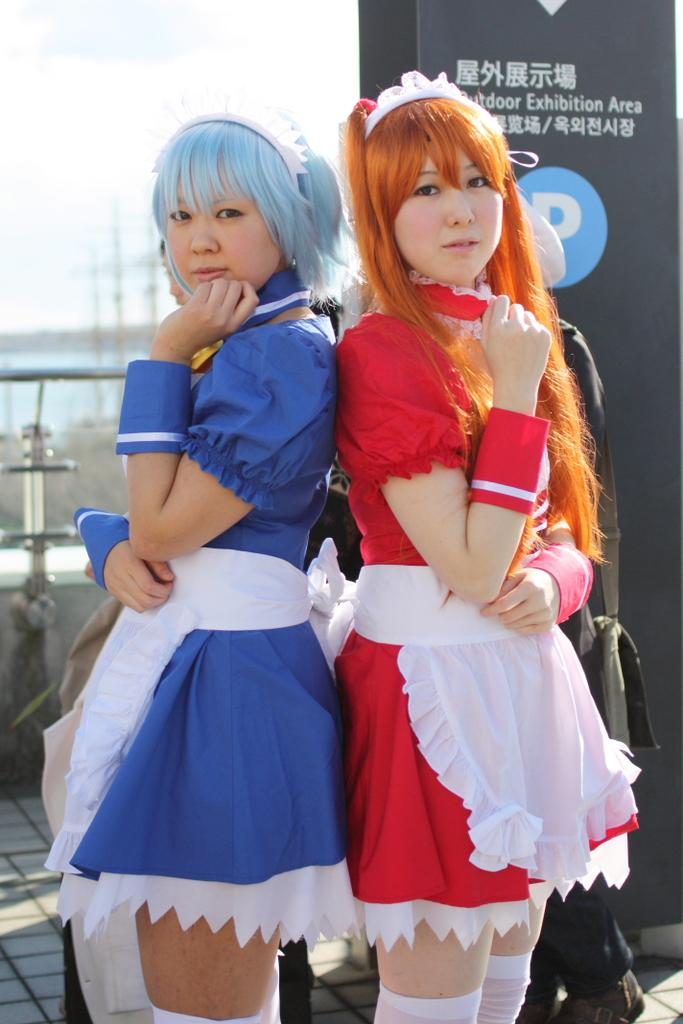How many women are in the image? There are two women in the image. What colors are the dresses worn by the women? One woman is wearing a blue dress, and the other woman is wearing a red dress. What colors of hair can be seen in the image? Blue hair and brown hair are visible in the image. What is in the background of the image? There is a railing and the sky visible in the background of the image. What is the profit margin of the business depicted in the image? There is no indication of a business or profit margin in the image. What season is depicted in the image? The image does not provide any information about the season, as there are no seasonal cues or    context. 